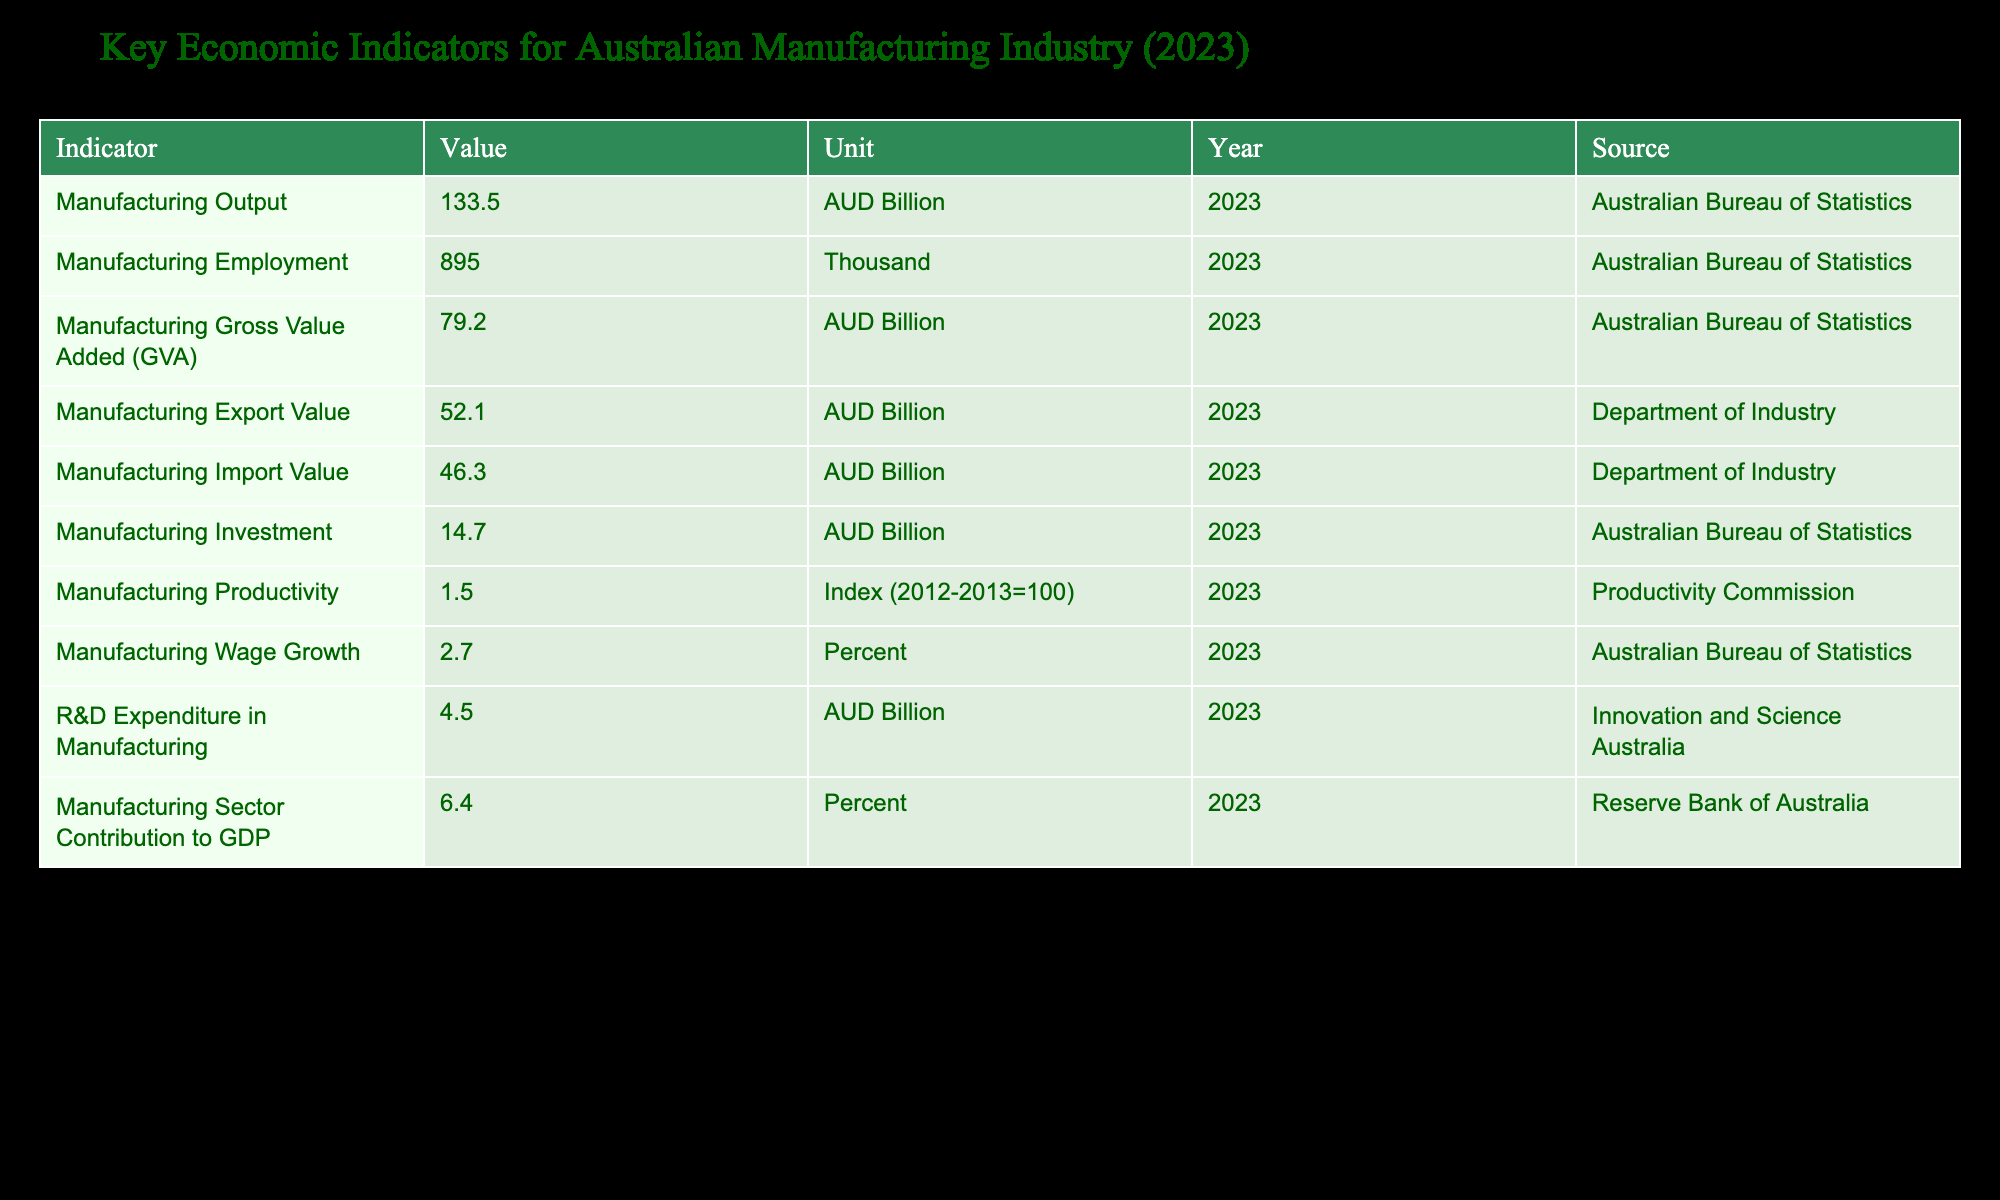What is the value of Manufacturing Output in 2023? The Manufacturing Output value is listed in the table, specifically in the row labeled "Manufacturing Output." It shows "133.5 AUD Billion."
Answer: 133.5 AUD Billion How many people are employed in the manufacturing sector in 2023? The employment figure can be found in the row labeled "Manufacturing Employment," which states "895 Thousand."
Answer: 895 Thousand What is the difference between Manufacturing Export Value and Manufactured Import Value? To find the difference, we subtract the Manufacturing Import Value (46.3 AUD Billion) from the Manufacturing Export Value (52.1 AUD Billion). Thus, 52.1 - 46.3 = 5.8 AUD Billion.
Answer: 5.8 AUD Billion Is the Manufacturing Gross Value Added greater than the Manufacturing Investment? Compare the values listed for Manufacturing Gross Value Added (79.2 AUD Billion) and Manufacturing Investment (14.7 AUD Billion). Since 79.2 is greater than 14.7, the statement is true.
Answer: Yes What is the contribution of the manufacturing sector to Australia’s GDP and how does it relate to its investment? The manufacturing sector contributes 6.4 percent to GDP, while Manufacturing Investment is noted as 14.7 AUD Billion. Comparing it shows a healthy sector as the contribution percentage indicates a significant economic role, despite being less than the total investment value.
Answer: 6.4 percent contribution to GDP What is the average Manufacturing Wage Growth and R&D Expenditure in Manufacturing? The Manufacturing Wage Growth is 2.7 percent and the R&D Expenditure is 4.5 AUD Billion. To find the average of these two different measures, we'd consider the specific values rather than directly averaging dissimilar units. However, they both highlight investment in human resources and research.
Answer: Not applicable for average due to differing units What greater value does the Manufacturing Output have compared to the Manufacturing Gross Value Added? Subtract the Manufacturing Gross Value Added (79.2 AUD Billion) from the Manufacturing Output (133.5 AUD Billion). This results in 133.5 - 79.2 = 54.3 AUD Billion, indicating a significant output surplus.
Answer: 54.3 AUD Billion Is the Manufacturing Investment higher than or equal to the R&D Expenditure? The values to compare are Manufacturing Investment (14.7 AUD Billion) and R&D Expenditure (4.5 AUD Billion). Since 14.7 is greater than 4.5, the statement is true.
Answer: Yes 